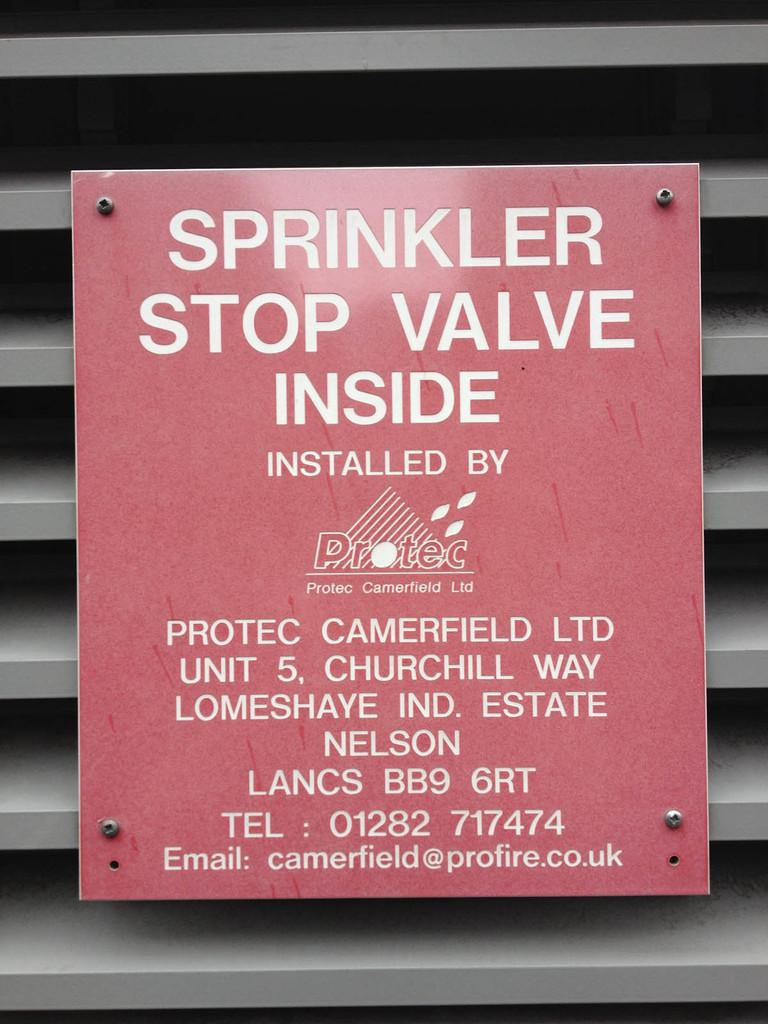<image>
Describe the image concisely. a poster in red titled 'sprinkler, stop valve inside'/ 